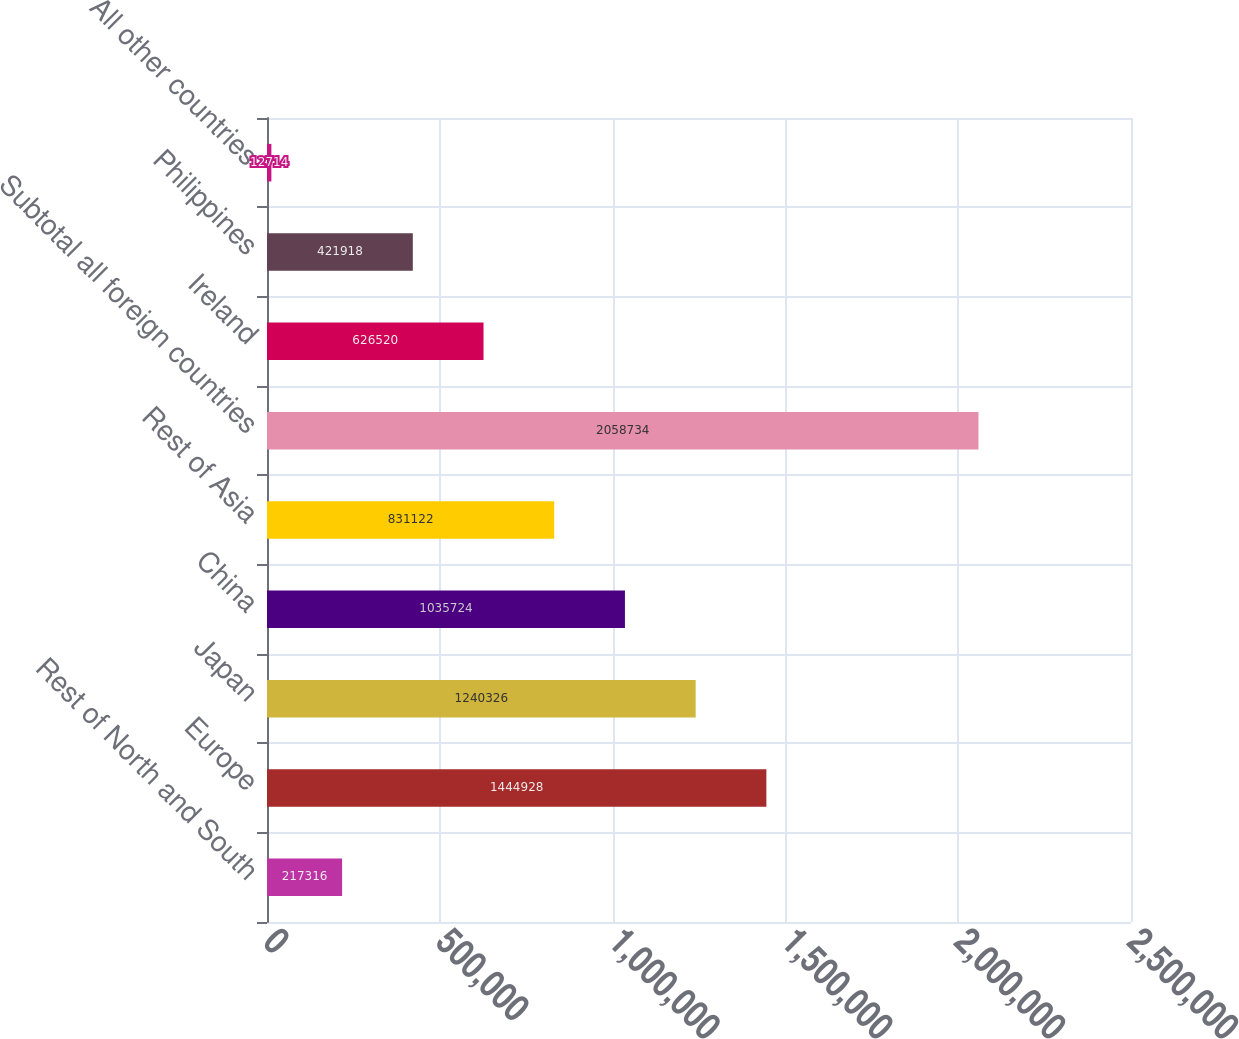<chart> <loc_0><loc_0><loc_500><loc_500><bar_chart><fcel>Rest of North and South<fcel>Europe<fcel>Japan<fcel>China<fcel>Rest of Asia<fcel>Subtotal all foreign countries<fcel>Ireland<fcel>Philippines<fcel>All other countries<nl><fcel>217316<fcel>1.44493e+06<fcel>1.24033e+06<fcel>1.03572e+06<fcel>831122<fcel>2.05873e+06<fcel>626520<fcel>421918<fcel>12714<nl></chart> 